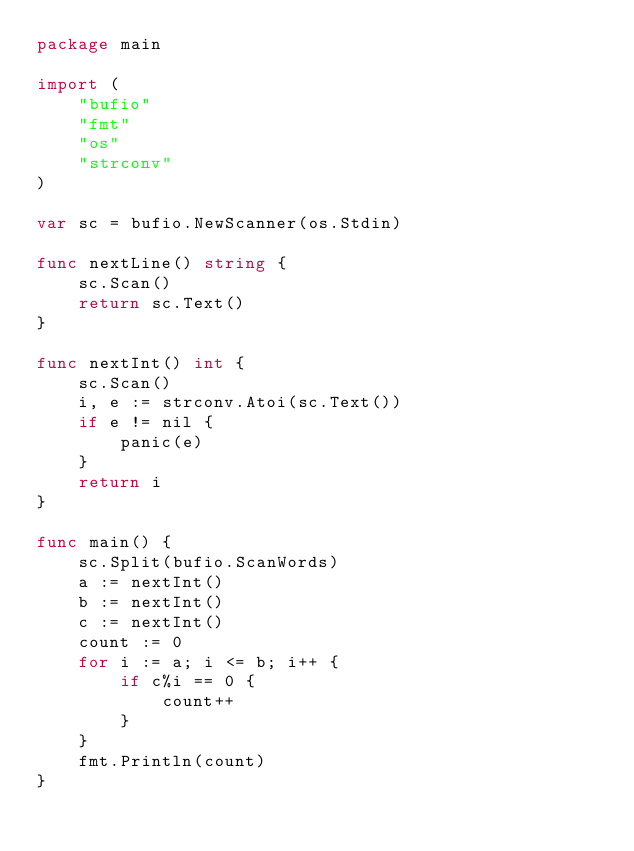Convert code to text. <code><loc_0><loc_0><loc_500><loc_500><_Go_>package main

import (
	"bufio"
	"fmt"
	"os"
	"strconv"
)

var sc = bufio.NewScanner(os.Stdin)

func nextLine() string {
	sc.Scan()
	return sc.Text()
}

func nextInt() int {
	sc.Scan()
	i, e := strconv.Atoi(sc.Text())
	if e != nil {
		panic(e)
	}
	return i
}

func main() {
	sc.Split(bufio.ScanWords)
	a := nextInt()
	b := nextInt()
	c := nextInt()
	count := 0
	for i := a; i <= b; i++ {
		if c%i == 0 {
			count++
		}
	}
	fmt.Println(count)
}

</code> 